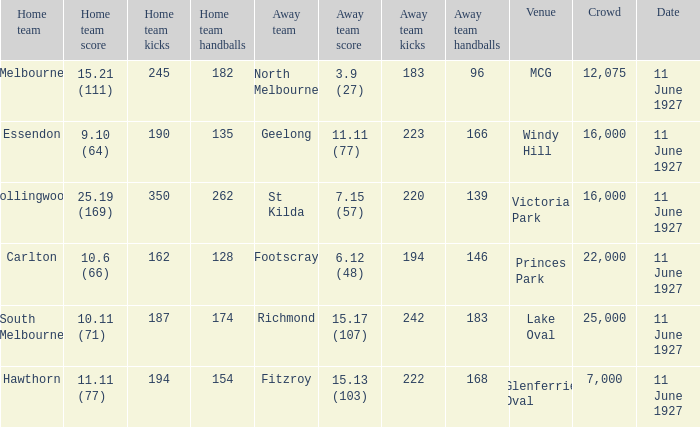How many people were in the crowd when Essendon was the home team? 1.0. 